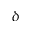Convert formula to latex. <formula><loc_0><loc_0><loc_500><loc_500>\delta</formula> 